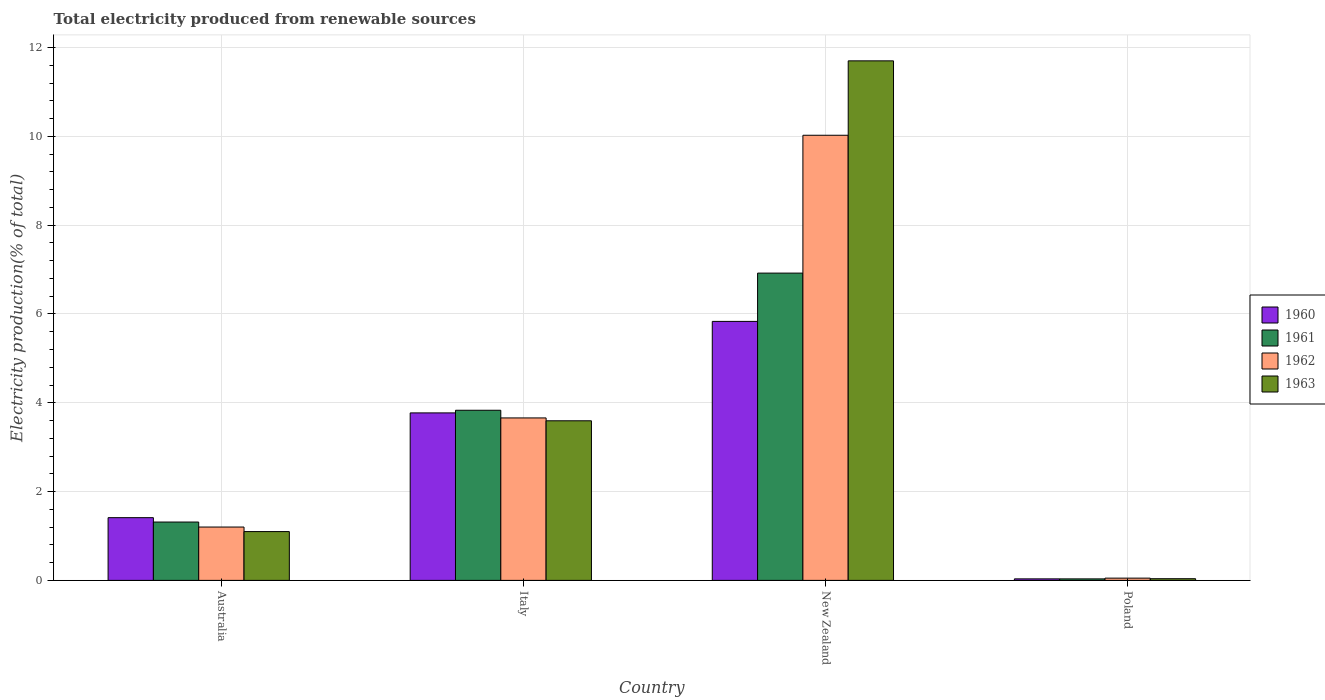How many groups of bars are there?
Provide a succinct answer. 4. Are the number of bars per tick equal to the number of legend labels?
Ensure brevity in your answer.  Yes. How many bars are there on the 4th tick from the right?
Give a very brief answer. 4. What is the label of the 3rd group of bars from the left?
Make the answer very short. New Zealand. In how many cases, is the number of bars for a given country not equal to the number of legend labels?
Provide a succinct answer. 0. What is the total electricity produced in 1963 in Poland?
Keep it short and to the point. 0.04. Across all countries, what is the maximum total electricity produced in 1960?
Provide a short and direct response. 5.83. Across all countries, what is the minimum total electricity produced in 1960?
Provide a short and direct response. 0.03. In which country was the total electricity produced in 1963 maximum?
Your answer should be compact. New Zealand. What is the total total electricity produced in 1960 in the graph?
Give a very brief answer. 11.05. What is the difference between the total electricity produced in 1962 in New Zealand and that in Poland?
Offer a terse response. 9.97. What is the difference between the total electricity produced in 1960 in Italy and the total electricity produced in 1961 in New Zealand?
Your answer should be compact. -3.15. What is the average total electricity produced in 1961 per country?
Your response must be concise. 3.02. What is the difference between the total electricity produced of/in 1962 and total electricity produced of/in 1960 in Italy?
Make the answer very short. -0.11. What is the ratio of the total electricity produced in 1961 in Italy to that in New Zealand?
Provide a short and direct response. 0.55. Is the difference between the total electricity produced in 1962 in Australia and Italy greater than the difference between the total electricity produced in 1960 in Australia and Italy?
Provide a short and direct response. No. What is the difference between the highest and the second highest total electricity produced in 1962?
Ensure brevity in your answer.  -8.82. What is the difference between the highest and the lowest total electricity produced in 1962?
Your answer should be very brief. 9.97. In how many countries, is the total electricity produced in 1962 greater than the average total electricity produced in 1962 taken over all countries?
Offer a terse response. 1. Is it the case that in every country, the sum of the total electricity produced in 1960 and total electricity produced in 1961 is greater than the sum of total electricity produced in 1962 and total electricity produced in 1963?
Provide a succinct answer. No. What does the 4th bar from the right in Australia represents?
Keep it short and to the point. 1960. How many bars are there?
Provide a short and direct response. 16. What is the difference between two consecutive major ticks on the Y-axis?
Provide a short and direct response. 2. Are the values on the major ticks of Y-axis written in scientific E-notation?
Your answer should be very brief. No. Does the graph contain any zero values?
Give a very brief answer. No. Where does the legend appear in the graph?
Ensure brevity in your answer.  Center right. What is the title of the graph?
Offer a terse response. Total electricity produced from renewable sources. Does "2014" appear as one of the legend labels in the graph?
Your response must be concise. No. What is the Electricity production(% of total) in 1960 in Australia?
Make the answer very short. 1.41. What is the Electricity production(% of total) in 1961 in Australia?
Provide a short and direct response. 1.31. What is the Electricity production(% of total) of 1962 in Australia?
Give a very brief answer. 1.2. What is the Electricity production(% of total) in 1963 in Australia?
Make the answer very short. 1.1. What is the Electricity production(% of total) of 1960 in Italy?
Keep it short and to the point. 3.77. What is the Electricity production(% of total) of 1961 in Italy?
Offer a very short reply. 3.83. What is the Electricity production(% of total) of 1962 in Italy?
Offer a terse response. 3.66. What is the Electricity production(% of total) of 1963 in Italy?
Offer a very short reply. 3.59. What is the Electricity production(% of total) of 1960 in New Zealand?
Keep it short and to the point. 5.83. What is the Electricity production(% of total) of 1961 in New Zealand?
Offer a very short reply. 6.92. What is the Electricity production(% of total) of 1962 in New Zealand?
Your response must be concise. 10.02. What is the Electricity production(% of total) in 1963 in New Zealand?
Your answer should be compact. 11.7. What is the Electricity production(% of total) of 1960 in Poland?
Your answer should be very brief. 0.03. What is the Electricity production(% of total) of 1961 in Poland?
Give a very brief answer. 0.03. What is the Electricity production(% of total) of 1962 in Poland?
Offer a terse response. 0.05. What is the Electricity production(% of total) in 1963 in Poland?
Provide a short and direct response. 0.04. Across all countries, what is the maximum Electricity production(% of total) of 1960?
Make the answer very short. 5.83. Across all countries, what is the maximum Electricity production(% of total) of 1961?
Give a very brief answer. 6.92. Across all countries, what is the maximum Electricity production(% of total) in 1962?
Offer a terse response. 10.02. Across all countries, what is the maximum Electricity production(% of total) in 1963?
Offer a terse response. 11.7. Across all countries, what is the minimum Electricity production(% of total) in 1960?
Provide a succinct answer. 0.03. Across all countries, what is the minimum Electricity production(% of total) in 1961?
Offer a terse response. 0.03. Across all countries, what is the minimum Electricity production(% of total) of 1962?
Your answer should be very brief. 0.05. Across all countries, what is the minimum Electricity production(% of total) in 1963?
Make the answer very short. 0.04. What is the total Electricity production(% of total) of 1960 in the graph?
Your answer should be very brief. 11.05. What is the total Electricity production(% of total) in 1961 in the graph?
Your answer should be very brief. 12.1. What is the total Electricity production(% of total) in 1962 in the graph?
Ensure brevity in your answer.  14.94. What is the total Electricity production(% of total) in 1963 in the graph?
Provide a short and direct response. 16.43. What is the difference between the Electricity production(% of total) of 1960 in Australia and that in Italy?
Give a very brief answer. -2.36. What is the difference between the Electricity production(% of total) of 1961 in Australia and that in Italy?
Ensure brevity in your answer.  -2.52. What is the difference between the Electricity production(% of total) in 1962 in Australia and that in Italy?
Give a very brief answer. -2.46. What is the difference between the Electricity production(% of total) of 1963 in Australia and that in Italy?
Your answer should be very brief. -2.5. What is the difference between the Electricity production(% of total) of 1960 in Australia and that in New Zealand?
Provide a succinct answer. -4.42. What is the difference between the Electricity production(% of total) in 1961 in Australia and that in New Zealand?
Make the answer very short. -5.61. What is the difference between the Electricity production(% of total) of 1962 in Australia and that in New Zealand?
Make the answer very short. -8.82. What is the difference between the Electricity production(% of total) of 1963 in Australia and that in New Zealand?
Your response must be concise. -10.6. What is the difference between the Electricity production(% of total) in 1960 in Australia and that in Poland?
Your answer should be very brief. 1.38. What is the difference between the Electricity production(% of total) in 1961 in Australia and that in Poland?
Your answer should be very brief. 1.28. What is the difference between the Electricity production(% of total) in 1962 in Australia and that in Poland?
Give a very brief answer. 1.15. What is the difference between the Electricity production(% of total) of 1963 in Australia and that in Poland?
Provide a short and direct response. 1.06. What is the difference between the Electricity production(% of total) of 1960 in Italy and that in New Zealand?
Ensure brevity in your answer.  -2.06. What is the difference between the Electricity production(% of total) of 1961 in Italy and that in New Zealand?
Provide a short and direct response. -3.09. What is the difference between the Electricity production(% of total) in 1962 in Italy and that in New Zealand?
Provide a succinct answer. -6.37. What is the difference between the Electricity production(% of total) of 1963 in Italy and that in New Zealand?
Provide a succinct answer. -8.11. What is the difference between the Electricity production(% of total) in 1960 in Italy and that in Poland?
Your response must be concise. 3.74. What is the difference between the Electricity production(% of total) in 1961 in Italy and that in Poland?
Ensure brevity in your answer.  3.8. What is the difference between the Electricity production(% of total) of 1962 in Italy and that in Poland?
Ensure brevity in your answer.  3.61. What is the difference between the Electricity production(% of total) in 1963 in Italy and that in Poland?
Offer a terse response. 3.56. What is the difference between the Electricity production(% of total) in 1960 in New Zealand and that in Poland?
Ensure brevity in your answer.  5.8. What is the difference between the Electricity production(% of total) of 1961 in New Zealand and that in Poland?
Keep it short and to the point. 6.89. What is the difference between the Electricity production(% of total) of 1962 in New Zealand and that in Poland?
Offer a terse response. 9.97. What is the difference between the Electricity production(% of total) in 1963 in New Zealand and that in Poland?
Provide a short and direct response. 11.66. What is the difference between the Electricity production(% of total) of 1960 in Australia and the Electricity production(% of total) of 1961 in Italy?
Your response must be concise. -2.42. What is the difference between the Electricity production(% of total) of 1960 in Australia and the Electricity production(% of total) of 1962 in Italy?
Offer a terse response. -2.25. What is the difference between the Electricity production(% of total) in 1960 in Australia and the Electricity production(% of total) in 1963 in Italy?
Keep it short and to the point. -2.18. What is the difference between the Electricity production(% of total) of 1961 in Australia and the Electricity production(% of total) of 1962 in Italy?
Make the answer very short. -2.34. What is the difference between the Electricity production(% of total) of 1961 in Australia and the Electricity production(% of total) of 1963 in Italy?
Make the answer very short. -2.28. What is the difference between the Electricity production(% of total) in 1962 in Australia and the Electricity production(% of total) in 1963 in Italy?
Make the answer very short. -2.39. What is the difference between the Electricity production(% of total) of 1960 in Australia and the Electricity production(% of total) of 1961 in New Zealand?
Your answer should be compact. -5.51. What is the difference between the Electricity production(% of total) of 1960 in Australia and the Electricity production(% of total) of 1962 in New Zealand?
Your answer should be compact. -8.61. What is the difference between the Electricity production(% of total) in 1960 in Australia and the Electricity production(% of total) in 1963 in New Zealand?
Offer a terse response. -10.29. What is the difference between the Electricity production(% of total) of 1961 in Australia and the Electricity production(% of total) of 1962 in New Zealand?
Make the answer very short. -8.71. What is the difference between the Electricity production(% of total) in 1961 in Australia and the Electricity production(% of total) in 1963 in New Zealand?
Your answer should be compact. -10.39. What is the difference between the Electricity production(% of total) of 1962 in Australia and the Electricity production(% of total) of 1963 in New Zealand?
Provide a short and direct response. -10.5. What is the difference between the Electricity production(% of total) in 1960 in Australia and the Electricity production(% of total) in 1961 in Poland?
Provide a succinct answer. 1.38. What is the difference between the Electricity production(% of total) of 1960 in Australia and the Electricity production(% of total) of 1962 in Poland?
Provide a short and direct response. 1.36. What is the difference between the Electricity production(% of total) in 1960 in Australia and the Electricity production(% of total) in 1963 in Poland?
Make the answer very short. 1.37. What is the difference between the Electricity production(% of total) of 1961 in Australia and the Electricity production(% of total) of 1962 in Poland?
Your answer should be very brief. 1.26. What is the difference between the Electricity production(% of total) of 1961 in Australia and the Electricity production(% of total) of 1963 in Poland?
Your response must be concise. 1.28. What is the difference between the Electricity production(% of total) in 1962 in Australia and the Electricity production(% of total) in 1963 in Poland?
Offer a very short reply. 1.16. What is the difference between the Electricity production(% of total) of 1960 in Italy and the Electricity production(% of total) of 1961 in New Zealand?
Give a very brief answer. -3.15. What is the difference between the Electricity production(% of total) in 1960 in Italy and the Electricity production(% of total) in 1962 in New Zealand?
Your response must be concise. -6.25. What is the difference between the Electricity production(% of total) of 1960 in Italy and the Electricity production(% of total) of 1963 in New Zealand?
Keep it short and to the point. -7.93. What is the difference between the Electricity production(% of total) of 1961 in Italy and the Electricity production(% of total) of 1962 in New Zealand?
Give a very brief answer. -6.19. What is the difference between the Electricity production(% of total) of 1961 in Italy and the Electricity production(% of total) of 1963 in New Zealand?
Your response must be concise. -7.87. What is the difference between the Electricity production(% of total) of 1962 in Italy and the Electricity production(% of total) of 1963 in New Zealand?
Your answer should be compact. -8.04. What is the difference between the Electricity production(% of total) of 1960 in Italy and the Electricity production(% of total) of 1961 in Poland?
Provide a short and direct response. 3.74. What is the difference between the Electricity production(% of total) of 1960 in Italy and the Electricity production(% of total) of 1962 in Poland?
Offer a very short reply. 3.72. What is the difference between the Electricity production(% of total) in 1960 in Italy and the Electricity production(% of total) in 1963 in Poland?
Make the answer very short. 3.73. What is the difference between the Electricity production(% of total) of 1961 in Italy and the Electricity production(% of total) of 1962 in Poland?
Your response must be concise. 3.78. What is the difference between the Electricity production(% of total) in 1961 in Italy and the Electricity production(% of total) in 1963 in Poland?
Offer a terse response. 3.79. What is the difference between the Electricity production(% of total) in 1962 in Italy and the Electricity production(% of total) in 1963 in Poland?
Offer a terse response. 3.62. What is the difference between the Electricity production(% of total) in 1960 in New Zealand and the Electricity production(% of total) in 1961 in Poland?
Offer a very short reply. 5.8. What is the difference between the Electricity production(% of total) in 1960 in New Zealand and the Electricity production(% of total) in 1962 in Poland?
Provide a succinct answer. 5.78. What is the difference between the Electricity production(% of total) of 1960 in New Zealand and the Electricity production(% of total) of 1963 in Poland?
Ensure brevity in your answer.  5.79. What is the difference between the Electricity production(% of total) of 1961 in New Zealand and the Electricity production(% of total) of 1962 in Poland?
Make the answer very short. 6.87. What is the difference between the Electricity production(% of total) of 1961 in New Zealand and the Electricity production(% of total) of 1963 in Poland?
Provide a short and direct response. 6.88. What is the difference between the Electricity production(% of total) of 1962 in New Zealand and the Electricity production(% of total) of 1963 in Poland?
Make the answer very short. 9.99. What is the average Electricity production(% of total) in 1960 per country?
Ensure brevity in your answer.  2.76. What is the average Electricity production(% of total) of 1961 per country?
Your answer should be compact. 3.02. What is the average Electricity production(% of total) in 1962 per country?
Ensure brevity in your answer.  3.73. What is the average Electricity production(% of total) of 1963 per country?
Ensure brevity in your answer.  4.11. What is the difference between the Electricity production(% of total) in 1960 and Electricity production(% of total) in 1961 in Australia?
Give a very brief answer. 0.1. What is the difference between the Electricity production(% of total) of 1960 and Electricity production(% of total) of 1962 in Australia?
Make the answer very short. 0.21. What is the difference between the Electricity production(% of total) of 1960 and Electricity production(% of total) of 1963 in Australia?
Give a very brief answer. 0.31. What is the difference between the Electricity production(% of total) in 1961 and Electricity production(% of total) in 1962 in Australia?
Ensure brevity in your answer.  0.11. What is the difference between the Electricity production(% of total) in 1961 and Electricity production(% of total) in 1963 in Australia?
Offer a terse response. 0.21. What is the difference between the Electricity production(% of total) of 1962 and Electricity production(% of total) of 1963 in Australia?
Provide a succinct answer. 0.1. What is the difference between the Electricity production(% of total) in 1960 and Electricity production(% of total) in 1961 in Italy?
Keep it short and to the point. -0.06. What is the difference between the Electricity production(% of total) in 1960 and Electricity production(% of total) in 1962 in Italy?
Keep it short and to the point. 0.11. What is the difference between the Electricity production(% of total) in 1960 and Electricity production(% of total) in 1963 in Italy?
Offer a terse response. 0.18. What is the difference between the Electricity production(% of total) of 1961 and Electricity production(% of total) of 1962 in Italy?
Offer a terse response. 0.17. What is the difference between the Electricity production(% of total) in 1961 and Electricity production(% of total) in 1963 in Italy?
Ensure brevity in your answer.  0.24. What is the difference between the Electricity production(% of total) in 1962 and Electricity production(% of total) in 1963 in Italy?
Give a very brief answer. 0.06. What is the difference between the Electricity production(% of total) of 1960 and Electricity production(% of total) of 1961 in New Zealand?
Your answer should be very brief. -1.09. What is the difference between the Electricity production(% of total) in 1960 and Electricity production(% of total) in 1962 in New Zealand?
Your answer should be very brief. -4.19. What is the difference between the Electricity production(% of total) of 1960 and Electricity production(% of total) of 1963 in New Zealand?
Provide a succinct answer. -5.87. What is the difference between the Electricity production(% of total) of 1961 and Electricity production(% of total) of 1962 in New Zealand?
Make the answer very short. -3.1. What is the difference between the Electricity production(% of total) in 1961 and Electricity production(% of total) in 1963 in New Zealand?
Offer a terse response. -4.78. What is the difference between the Electricity production(% of total) in 1962 and Electricity production(% of total) in 1963 in New Zealand?
Offer a very short reply. -1.68. What is the difference between the Electricity production(% of total) of 1960 and Electricity production(% of total) of 1962 in Poland?
Keep it short and to the point. -0.02. What is the difference between the Electricity production(% of total) in 1960 and Electricity production(% of total) in 1963 in Poland?
Make the answer very short. -0. What is the difference between the Electricity production(% of total) of 1961 and Electricity production(% of total) of 1962 in Poland?
Your answer should be compact. -0.02. What is the difference between the Electricity production(% of total) in 1961 and Electricity production(% of total) in 1963 in Poland?
Ensure brevity in your answer.  -0. What is the difference between the Electricity production(% of total) in 1962 and Electricity production(% of total) in 1963 in Poland?
Make the answer very short. 0.01. What is the ratio of the Electricity production(% of total) in 1960 in Australia to that in Italy?
Provide a succinct answer. 0.37. What is the ratio of the Electricity production(% of total) in 1961 in Australia to that in Italy?
Your response must be concise. 0.34. What is the ratio of the Electricity production(% of total) in 1962 in Australia to that in Italy?
Ensure brevity in your answer.  0.33. What is the ratio of the Electricity production(% of total) of 1963 in Australia to that in Italy?
Your answer should be very brief. 0.31. What is the ratio of the Electricity production(% of total) in 1960 in Australia to that in New Zealand?
Make the answer very short. 0.24. What is the ratio of the Electricity production(% of total) of 1961 in Australia to that in New Zealand?
Provide a short and direct response. 0.19. What is the ratio of the Electricity production(% of total) of 1962 in Australia to that in New Zealand?
Provide a short and direct response. 0.12. What is the ratio of the Electricity production(% of total) in 1963 in Australia to that in New Zealand?
Keep it short and to the point. 0.09. What is the ratio of the Electricity production(% of total) of 1960 in Australia to that in Poland?
Your answer should be compact. 41.37. What is the ratio of the Electricity production(% of total) in 1961 in Australia to that in Poland?
Your answer should be very brief. 38.51. What is the ratio of the Electricity production(% of total) of 1962 in Australia to that in Poland?
Your answer should be compact. 23.61. What is the ratio of the Electricity production(% of total) in 1963 in Australia to that in Poland?
Make the answer very short. 29. What is the ratio of the Electricity production(% of total) in 1960 in Italy to that in New Zealand?
Offer a very short reply. 0.65. What is the ratio of the Electricity production(% of total) in 1961 in Italy to that in New Zealand?
Make the answer very short. 0.55. What is the ratio of the Electricity production(% of total) of 1962 in Italy to that in New Zealand?
Ensure brevity in your answer.  0.36. What is the ratio of the Electricity production(% of total) of 1963 in Italy to that in New Zealand?
Offer a very short reply. 0.31. What is the ratio of the Electricity production(% of total) of 1960 in Italy to that in Poland?
Provide a succinct answer. 110.45. What is the ratio of the Electricity production(% of total) of 1961 in Italy to that in Poland?
Provide a short and direct response. 112.3. What is the ratio of the Electricity production(% of total) of 1962 in Italy to that in Poland?
Your response must be concise. 71.88. What is the ratio of the Electricity production(% of total) in 1963 in Italy to that in Poland?
Your answer should be compact. 94.84. What is the ratio of the Electricity production(% of total) of 1960 in New Zealand to that in Poland?
Ensure brevity in your answer.  170.79. What is the ratio of the Electricity production(% of total) of 1961 in New Zealand to that in Poland?
Make the answer very short. 202.83. What is the ratio of the Electricity production(% of total) in 1962 in New Zealand to that in Poland?
Ensure brevity in your answer.  196.95. What is the ratio of the Electricity production(% of total) of 1963 in New Zealand to that in Poland?
Offer a very short reply. 308.73. What is the difference between the highest and the second highest Electricity production(% of total) in 1960?
Your answer should be very brief. 2.06. What is the difference between the highest and the second highest Electricity production(% of total) of 1961?
Offer a terse response. 3.09. What is the difference between the highest and the second highest Electricity production(% of total) in 1962?
Your answer should be very brief. 6.37. What is the difference between the highest and the second highest Electricity production(% of total) in 1963?
Keep it short and to the point. 8.11. What is the difference between the highest and the lowest Electricity production(% of total) in 1960?
Give a very brief answer. 5.8. What is the difference between the highest and the lowest Electricity production(% of total) in 1961?
Provide a short and direct response. 6.89. What is the difference between the highest and the lowest Electricity production(% of total) of 1962?
Give a very brief answer. 9.97. What is the difference between the highest and the lowest Electricity production(% of total) of 1963?
Offer a very short reply. 11.66. 